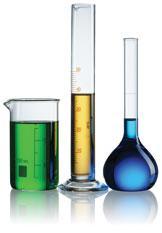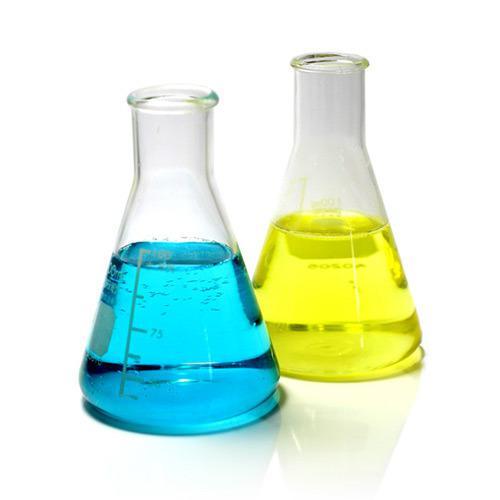The first image is the image on the left, the second image is the image on the right. Examine the images to the left and right. Is the description "There are no more than 5 laboratory flasks in the pair of images." accurate? Answer yes or no. Yes. The first image is the image on the left, the second image is the image on the right. Assess this claim about the two images: "All images show beakers and all beakers contain colored liquids.". Correct or not? Answer yes or no. Yes. 